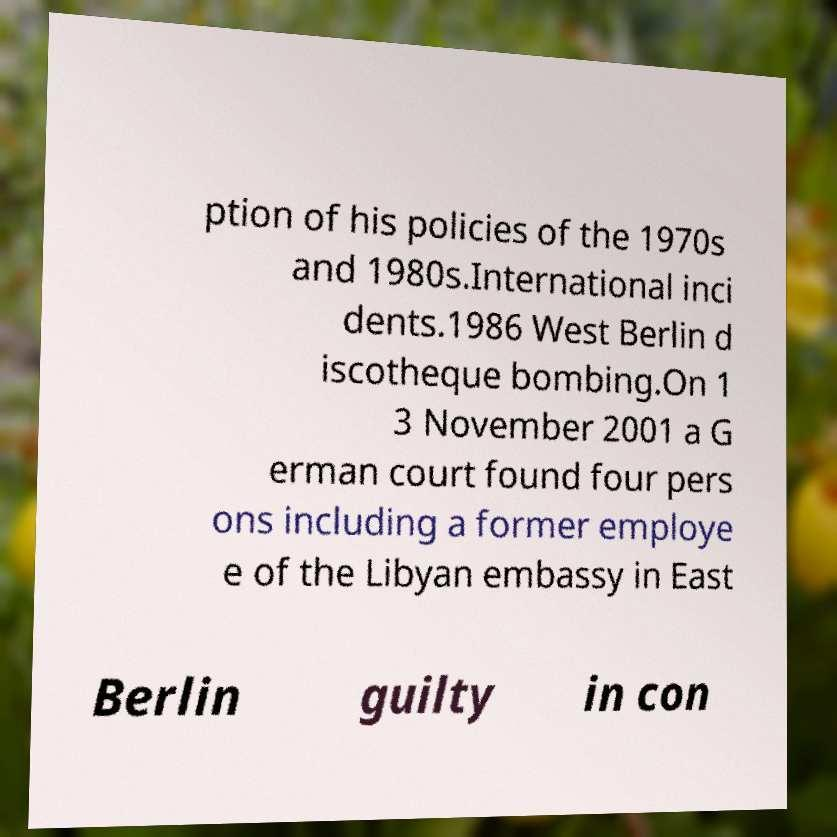Could you assist in decoding the text presented in this image and type it out clearly? ption of his policies of the 1970s and 1980s.International inci dents.1986 West Berlin d iscotheque bombing.On 1 3 November 2001 a G erman court found four pers ons including a former employe e of the Libyan embassy in East Berlin guilty in con 